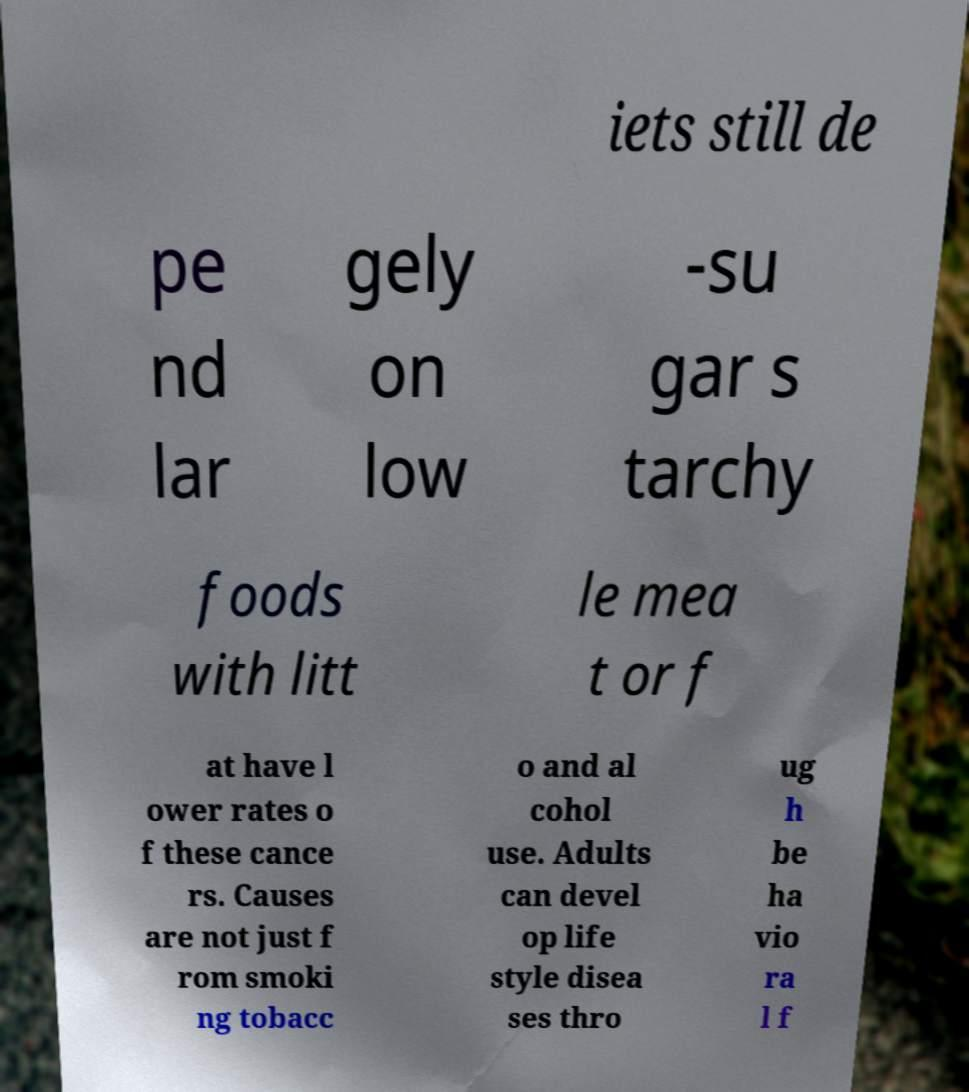What messages or text are displayed in this image? I need them in a readable, typed format. iets still de pe nd lar gely on low -su gar s tarchy foods with litt le mea t or f at have l ower rates o f these cance rs. Causes are not just f rom smoki ng tobacc o and al cohol use. Adults can devel op life style disea ses thro ug h be ha vio ra l f 